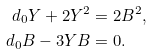Convert formula to latex. <formula><loc_0><loc_0><loc_500><loc_500>d _ { 0 } Y + 2 Y ^ { 2 } & = 2 B ^ { 2 } , \\ d _ { 0 } B - 3 Y B & = 0 .</formula> 